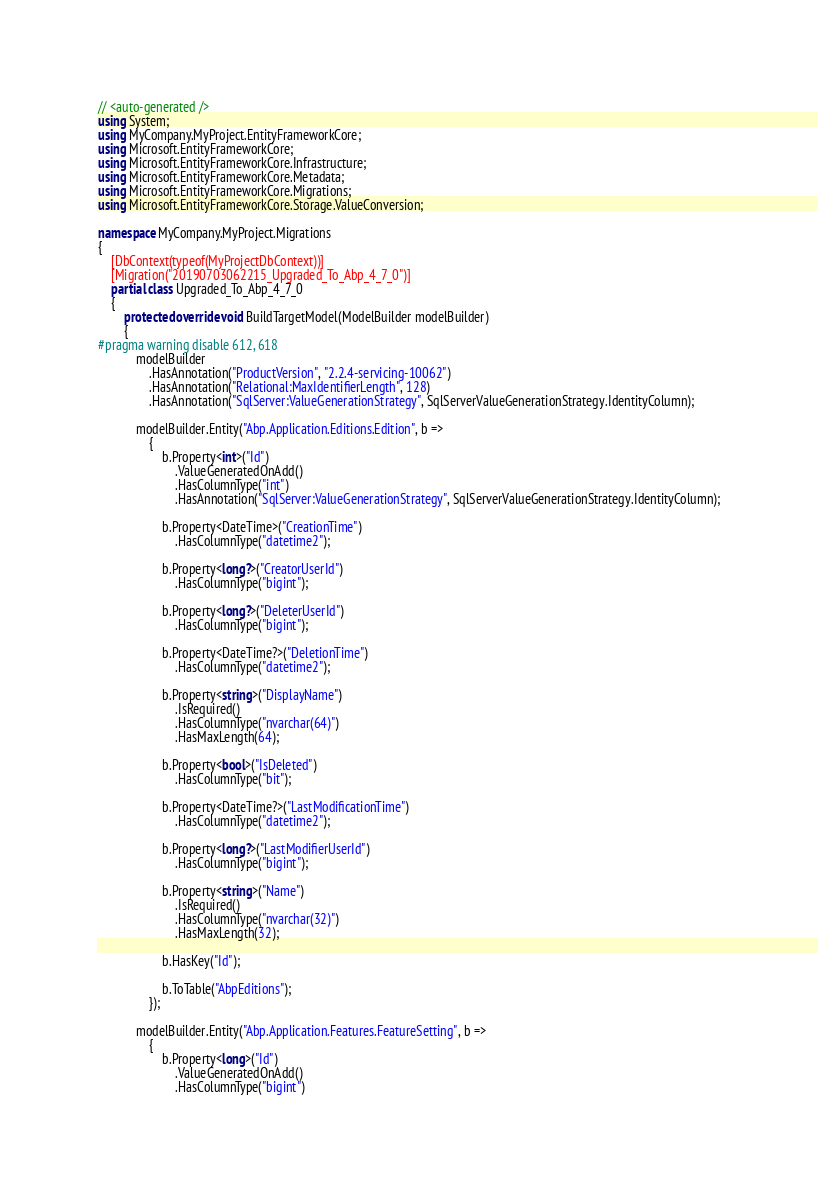Convert code to text. <code><loc_0><loc_0><loc_500><loc_500><_C#_>// <auto-generated />
using System;
using MyCompany.MyProject.EntityFrameworkCore;
using Microsoft.EntityFrameworkCore;
using Microsoft.EntityFrameworkCore.Infrastructure;
using Microsoft.EntityFrameworkCore.Metadata;
using Microsoft.EntityFrameworkCore.Migrations;
using Microsoft.EntityFrameworkCore.Storage.ValueConversion;

namespace MyCompany.MyProject.Migrations
{
    [DbContext(typeof(MyProjectDbContext))]
    [Migration("20190703062215_Upgraded_To_Abp_4_7_0")]
    partial class Upgraded_To_Abp_4_7_0
    {
        protected override void BuildTargetModel(ModelBuilder modelBuilder)
        {
#pragma warning disable 612, 618
            modelBuilder
                .HasAnnotation("ProductVersion", "2.2.4-servicing-10062")
                .HasAnnotation("Relational:MaxIdentifierLength", 128)
                .HasAnnotation("SqlServer:ValueGenerationStrategy", SqlServerValueGenerationStrategy.IdentityColumn);

            modelBuilder.Entity("Abp.Application.Editions.Edition", b =>
                {
                    b.Property<int>("Id")
                        .ValueGeneratedOnAdd()
                        .HasColumnType("int")
                        .HasAnnotation("SqlServer:ValueGenerationStrategy", SqlServerValueGenerationStrategy.IdentityColumn);

                    b.Property<DateTime>("CreationTime")
                        .HasColumnType("datetime2");

                    b.Property<long?>("CreatorUserId")
                        .HasColumnType("bigint");

                    b.Property<long?>("DeleterUserId")
                        .HasColumnType("bigint");

                    b.Property<DateTime?>("DeletionTime")
                        .HasColumnType("datetime2");

                    b.Property<string>("DisplayName")
                        .IsRequired()
                        .HasColumnType("nvarchar(64)")
                        .HasMaxLength(64);

                    b.Property<bool>("IsDeleted")
                        .HasColumnType("bit");

                    b.Property<DateTime?>("LastModificationTime")
                        .HasColumnType("datetime2");

                    b.Property<long?>("LastModifierUserId")
                        .HasColumnType("bigint");

                    b.Property<string>("Name")
                        .IsRequired()
                        .HasColumnType("nvarchar(32)")
                        .HasMaxLength(32);

                    b.HasKey("Id");

                    b.ToTable("AbpEditions");
                });

            modelBuilder.Entity("Abp.Application.Features.FeatureSetting", b =>
                {
                    b.Property<long>("Id")
                        .ValueGeneratedOnAdd()
                        .HasColumnType("bigint")</code> 